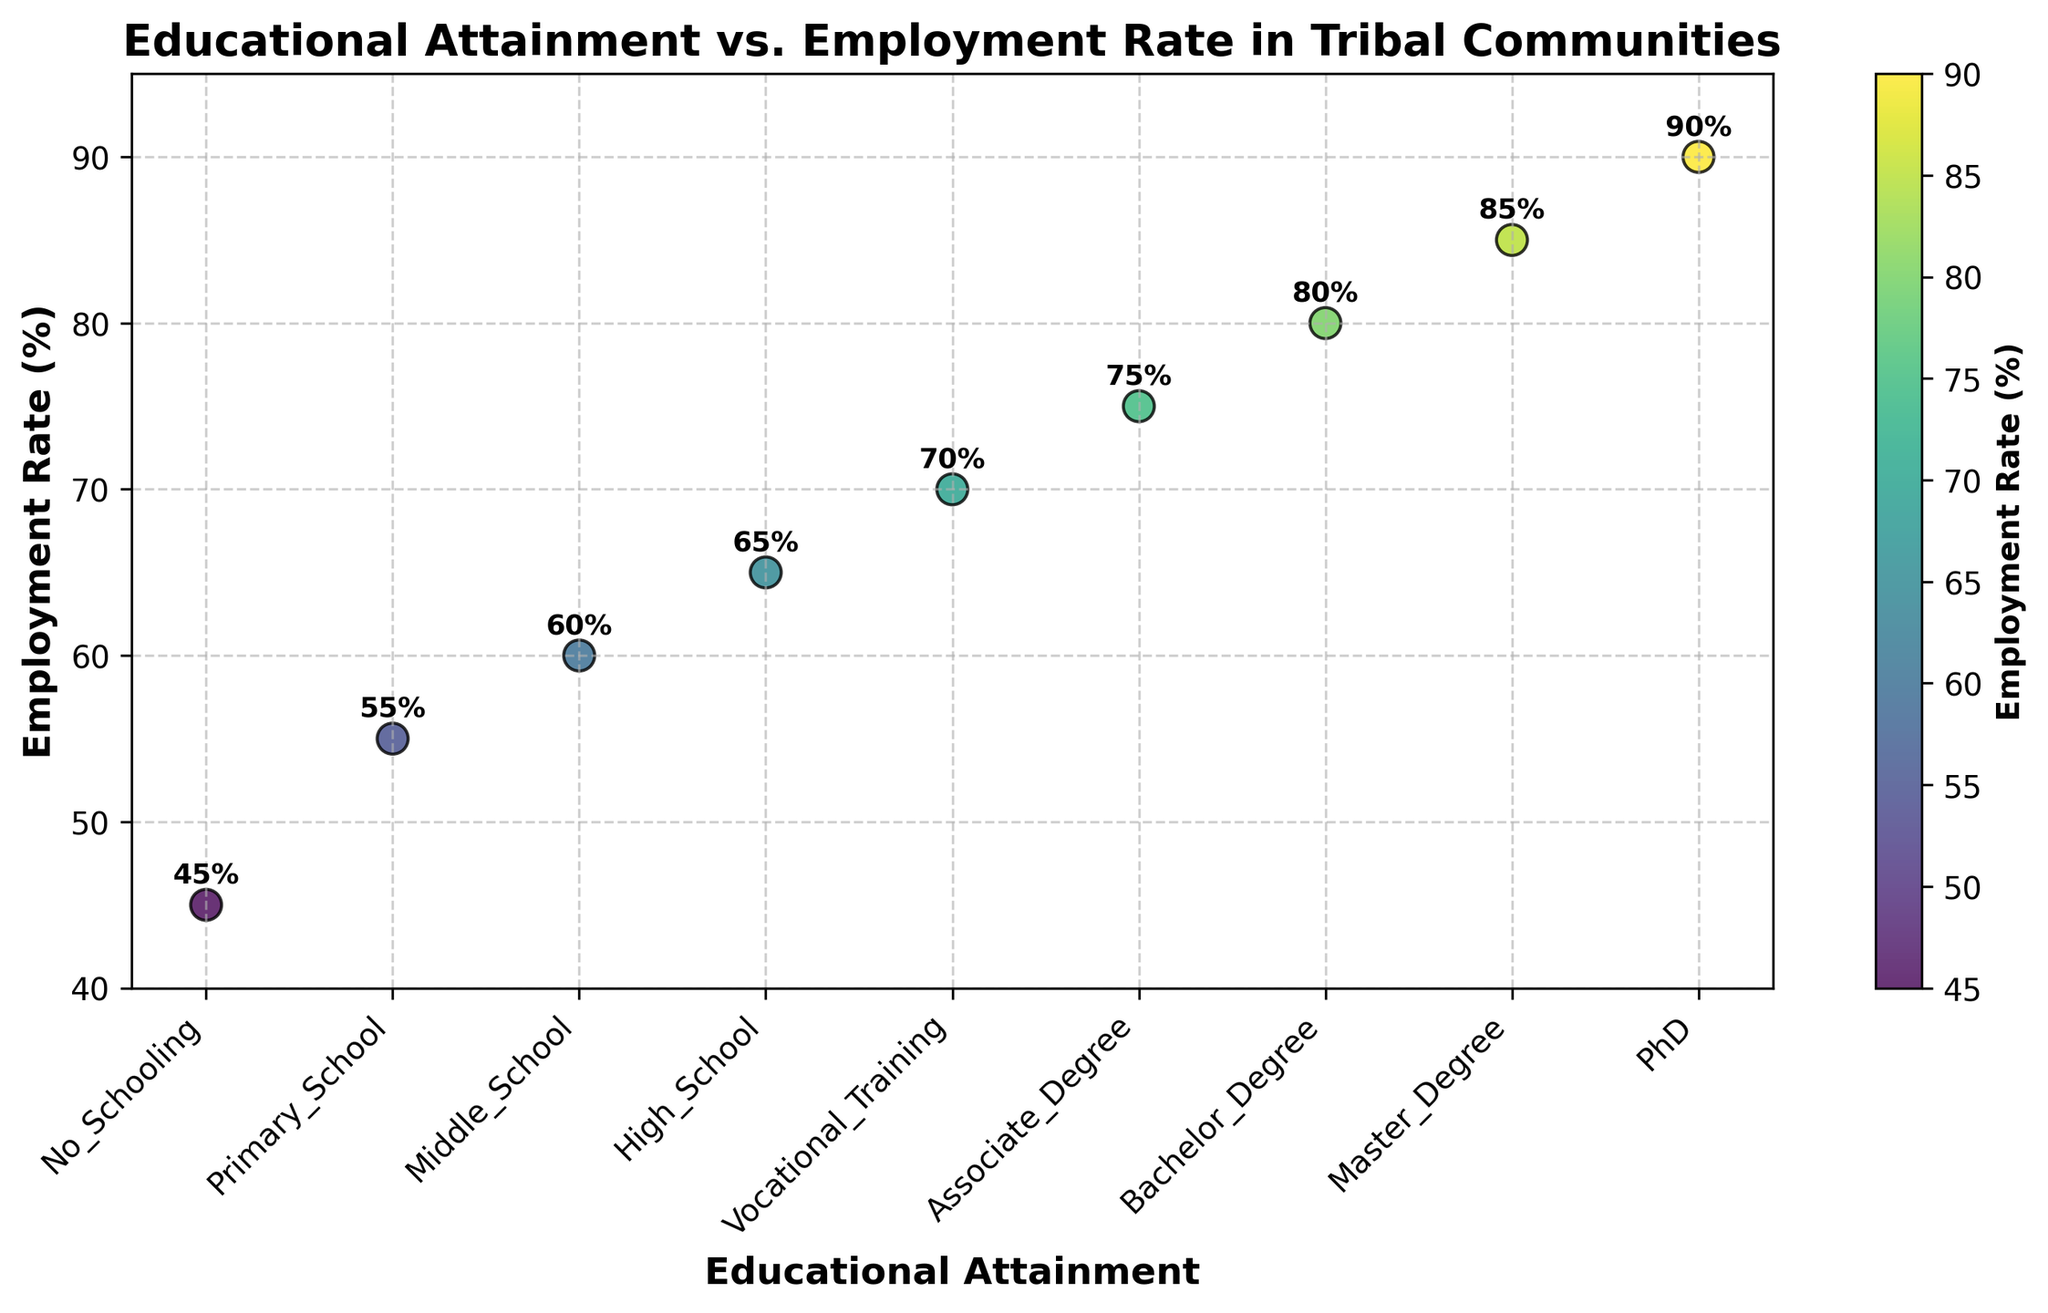What's the title of the plot? The title is written at the top of the plot.
Answer: Educational Attainment vs. Employment Rate in Tribal Communities How many educational attainment levels are represented in the plot? Count the number of unique educational levels on the x-axis.
Answer: 9 What is the employment rate for those with a bachelor's degree? Locate 'Bachelor_Degree' on the x-axis and check the corresponding y-value or the annotated text.
Answer: 80% Which educational attainment level has the lowest employment rate? Identify the lowest y-value (or the text annotation with the smallest percentage) and check the corresponding x-label.
Answer: No_Schooling What is the average employment rate across all educational attainment levels? Sum all the employment rate values and divide by the number of data points: (45 + 55 + 60 + 65 + 70 + 75 + 80 + 85 + 90) / 9 = 625 / 9 ≈ 69.44
Answer: 69.44% Is the employment rate for 'Vocational Training' higher than that for 'Middle School'? Compare the y-values for 'Vocational Training' and 'Middle School'.
Answer: Yes Which educational level has a higher employment rate: 'High School' or 'Associate Degree'? Compare the y-values or text annotations for 'High School' and 'Associate Degree'.
Answer: Associate Degree What's the difference in employment rate between 'Primary School' and 'PhD'? Subtract the employment rate for 'Primary School' from that for 'PhD': 90 - 55 = 35%
Answer: 35% Is there an evident trend between educational attainment and employment rate? Observe the general direction of the plot points from 'No_Schooling' to 'PhD'. The employment rate increases as the level of educational attainment increases.
Answer: Yes How is the diversity of employment rates visually represented on the scatter plot? The color of the points changes with employment rates, and a color bar indicates the gradient of employment rates.
Answer: By color gradient and a color bar 